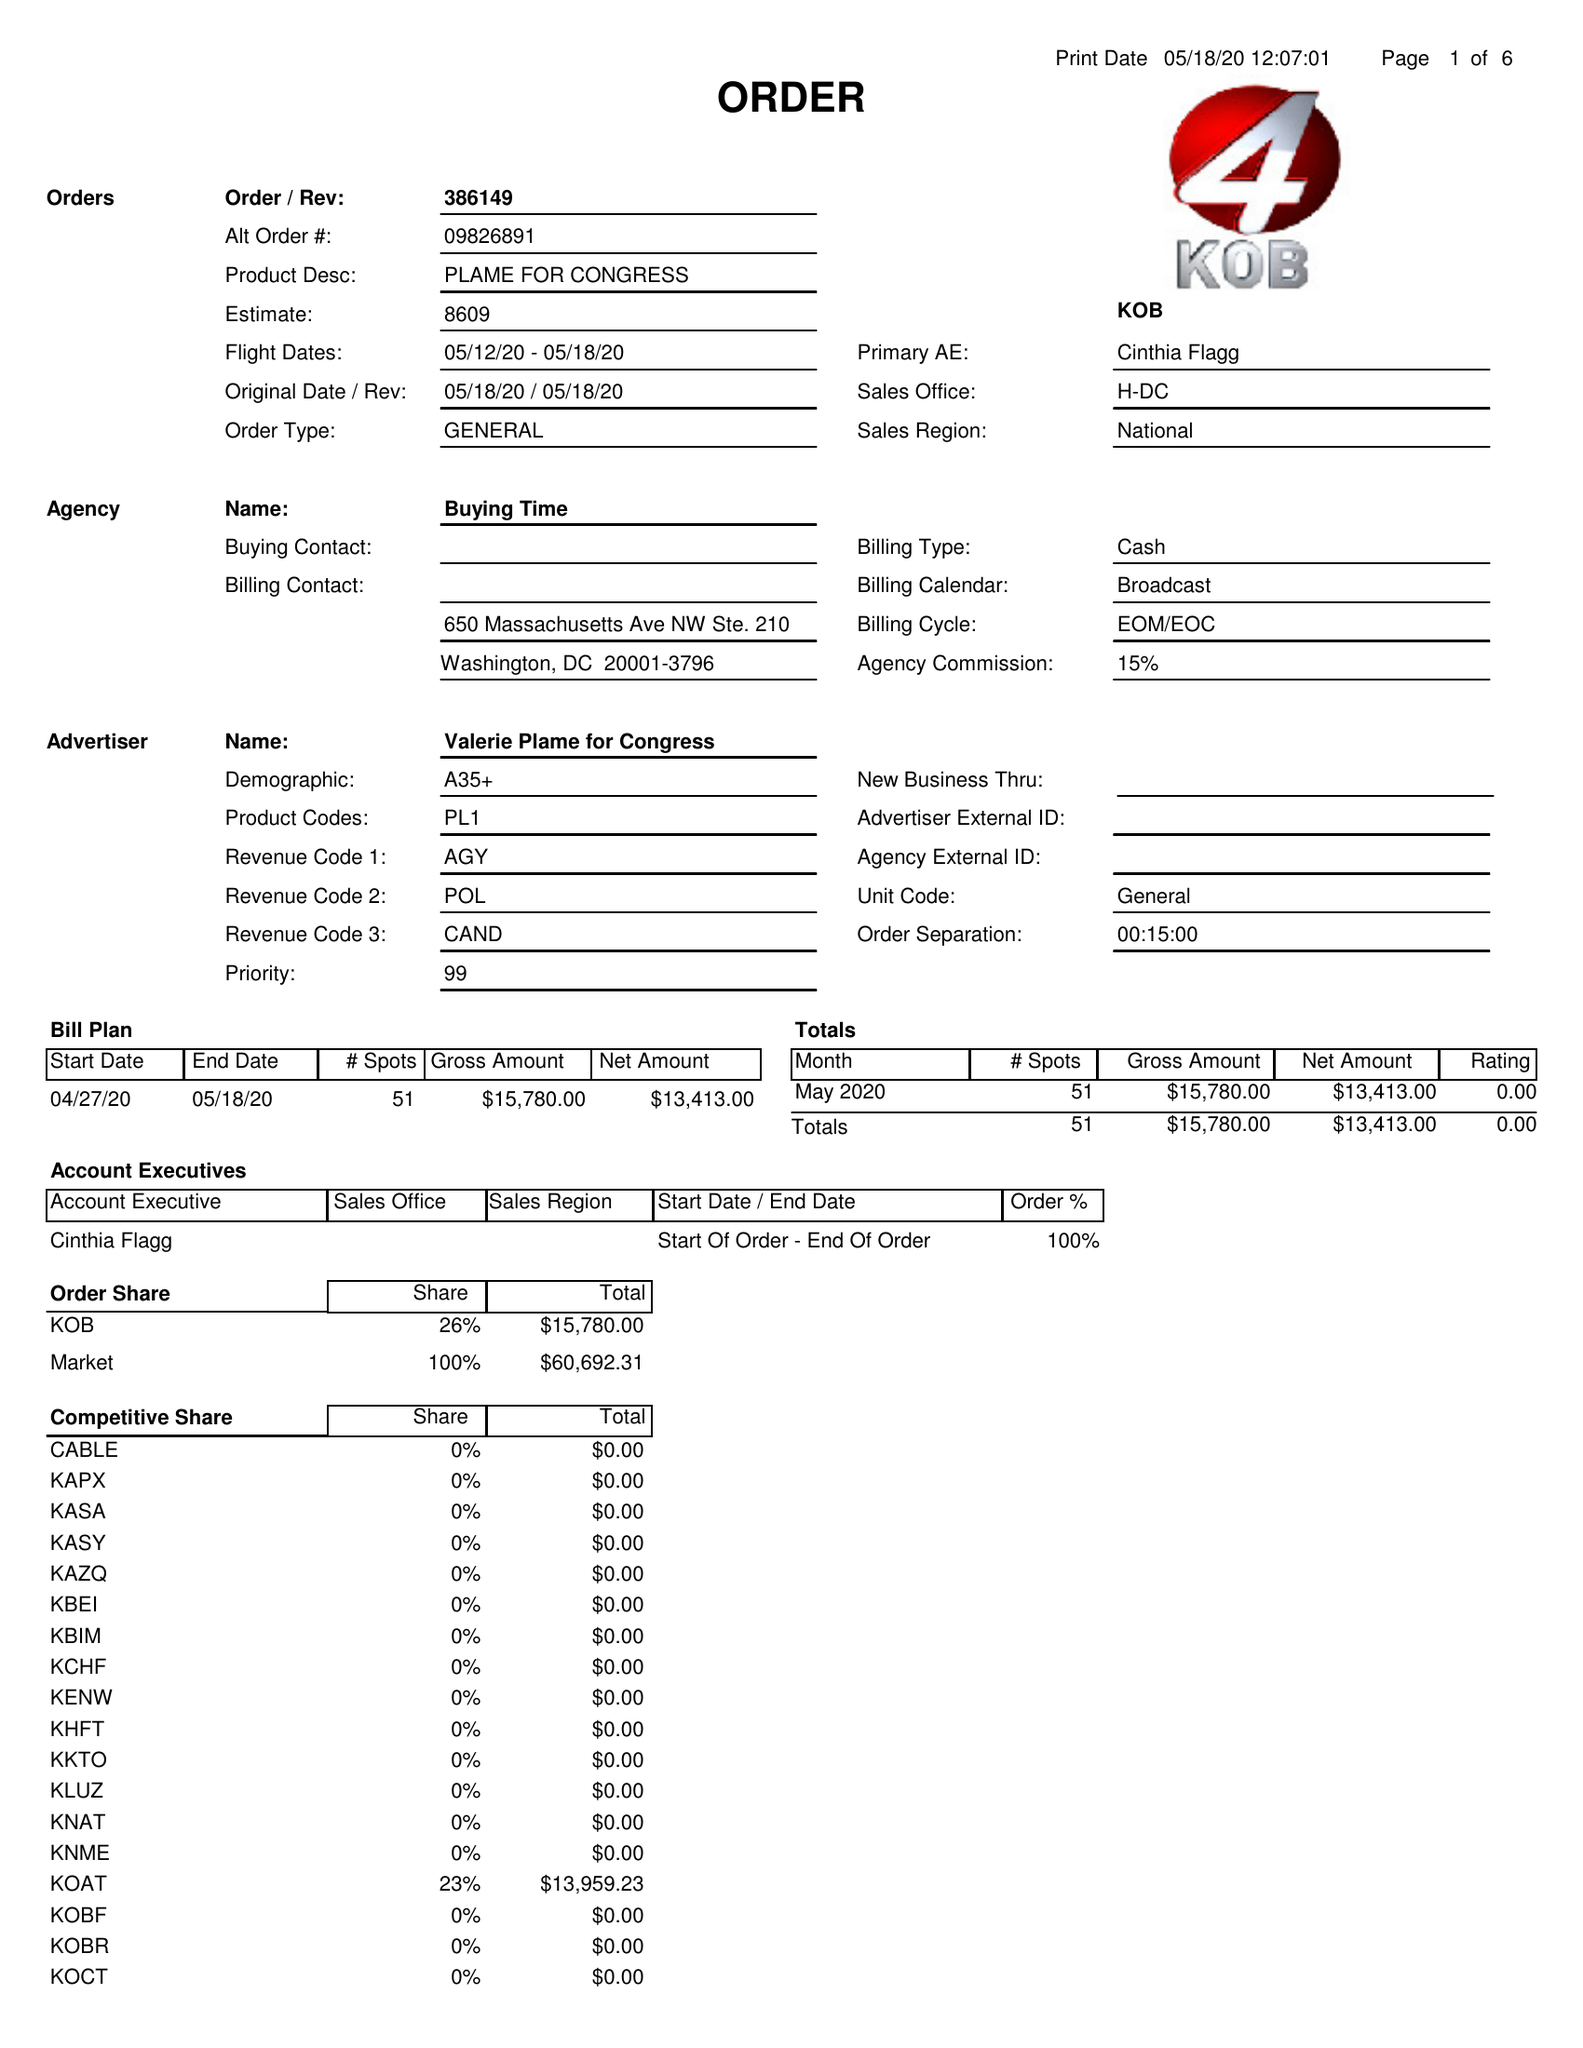What is the value for the advertiser?
Answer the question using a single word or phrase. PLAME FOR CONGRESS 